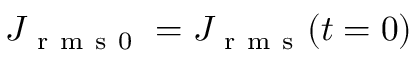Convert formula to latex. <formula><loc_0><loc_0><loc_500><loc_500>J _ { r m s 0 } = J _ { r m s } ( t = 0 )</formula> 